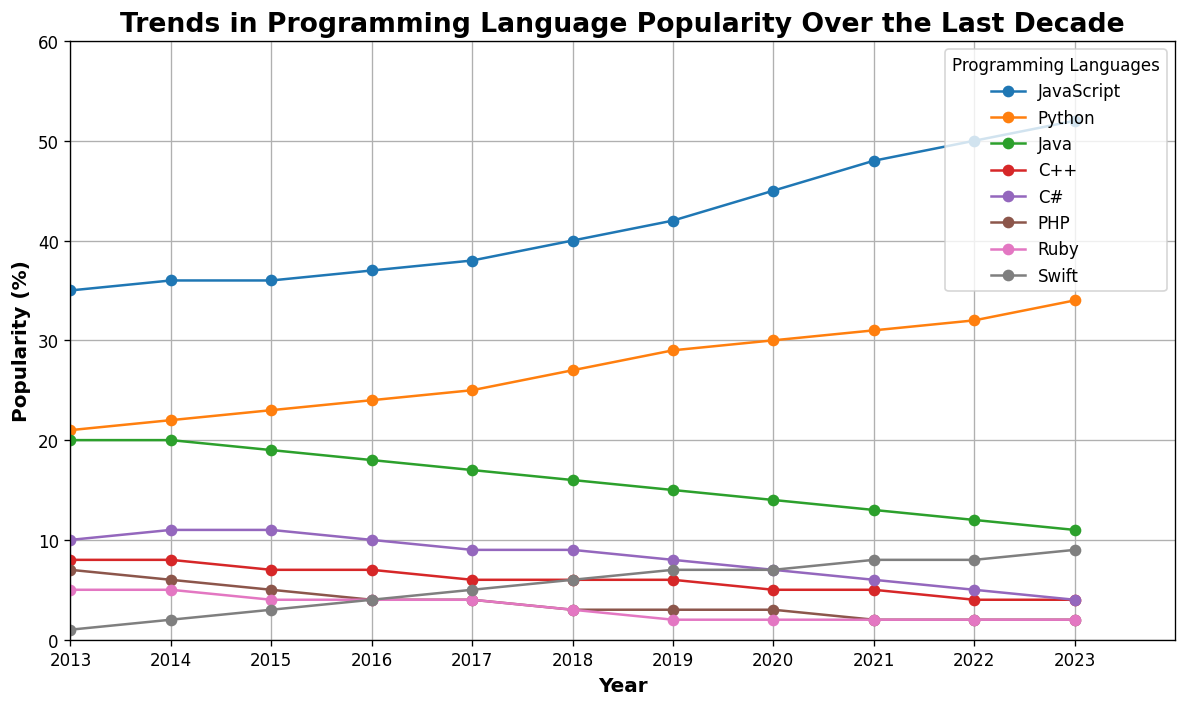Which programming language has the highest popularity in 2023? The figure shows that JavaScript has the highest popularity in 2023 among all the languages plotted. This is visible as the line for JavaScript is at the highest point on the y-axis in 2023.
Answer: JavaScript Which language experienced the steepest increase in popularity from 2013 to 2023? By visually analyzing the slopes of all lines from 2013 to 2023, Python shows the steepest increase. Its line rises from 21% in 2013 to 34% in 2023.
Answer: Python Between which two years did Swift see the most significant rise in popularity? Looking at the plot, Swift had the greatest rise between 2013 and 2014, where its line saw a marked increase from 1% to 2%.
Answer: 2013 to 2014 How much did the popularity of Java decrease from 2013 to 2023? The popularity of Java in 2013 was 20%, and it decreased to 11% in 2023. The difference is calculated by 20% - 11% = 9%.
Answer: 9% In which year did C++ first drop below 6% popularity? The figure indicates that C++ first dropped below 6% in the year 2017, as the line crosses below 6% between 2016 and 2017.
Answer: 2017 Which language had a consistent decrease in popularity over the last decade? PHP consistently decreased over the last decade from 7% in 2013 to 2% in 2023, as its line steadily descends without any upward movements.
Answer: PHP Compare the popularity of Python and Java in 2020. By how many percentage points does Python exceed Java in that year? In 2020, Python has a popularity of 30% while Java has 14%. The difference is calculated by 30% - 14% = 16%.
Answer: 16 What is the average popularity of Swift over the decade 2013-2023? The values for Swift from 2013 to 2023 are: 1, 2, 3, 4, 5, 6, 7, 7, 8, 8, and 9%. Summing these values gives 60. Dividing by the number of years (11) gives 60/11 ≈ 5.45%.
Answer: 5.45 Which language's popularity remains the same from 2022 to 2023? Both Ruby and Swift had the same popularity from 2022 to 2023, as their lines in the plot are horizontal between these two years.
Answer: Ruby, Swift 